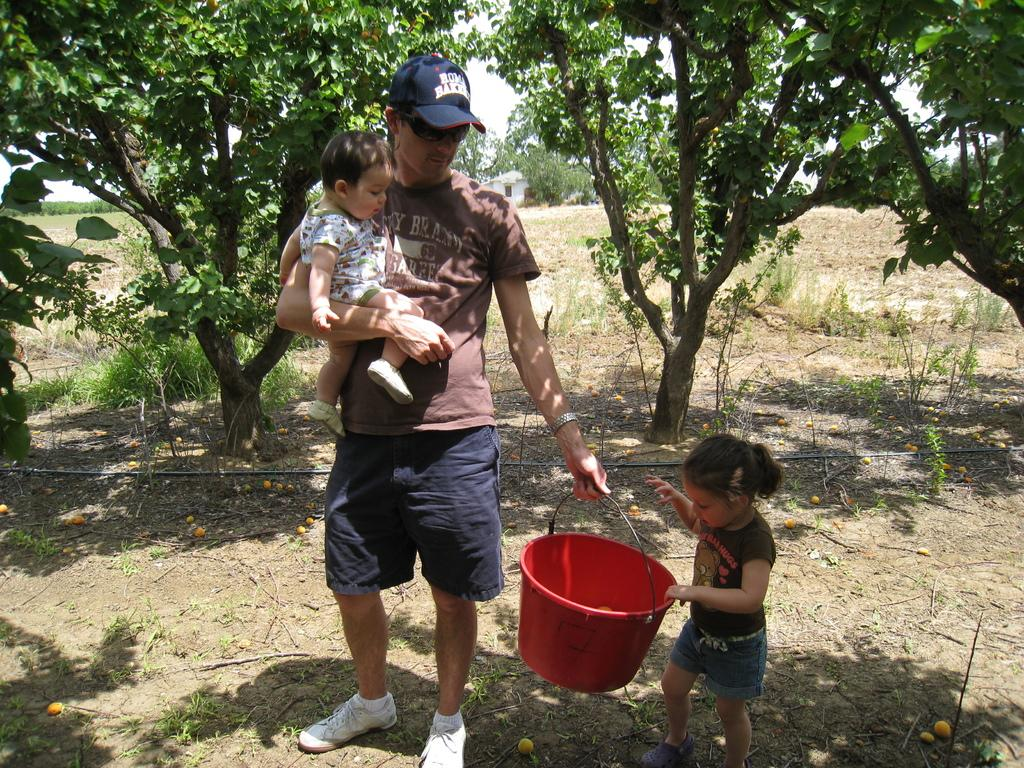What is the man in the image doing? The man is standing in the image and holding a child and a bucket. Can you describe the position of the man and child in the image? The man and child are in the middle of the image. Are there any other children visible in the image? Yes, there is another child on the right side of the image. What can be seen in the background of the image? Trees are visible in the background of the image. What type of destruction can be seen in the image? There is no destruction present in the image; it features a man holding a child and a bucket, with another child and trees in the background. Can you describe the color and texture of the man's tongue in the image? There is no information about the man's tongue in the image, as it is not visible or mentioned in the provided facts. 